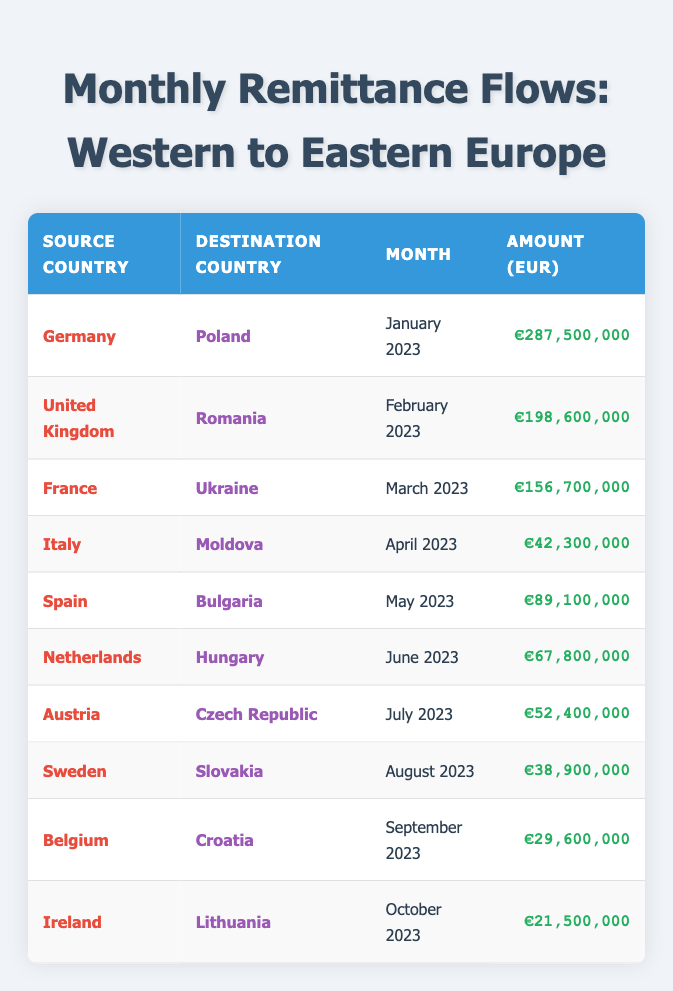What was the highest remittance flow recorded in the table? The highest remittance flow is found by scanning the "Amount (EUR)" column. The largest number listed is €287,500,000, which corresponds to Germany sending money to Poland in January 2023.
Answer: €287,500,000 How much money was sent from Italy to Moldova? By examining the table, I find that the amount sent from Italy to Moldova in April 2023 is €42,300,000 as indicated in the "Amount (EUR)" column.
Answer: €42,300,000 Which country received the least remittance in the table? Looking through the "Amount (EUR)" column, the smallest amount is €21,500,000 sent to Lithuania by Ireland in October 2023.
Answer: Lithuania What is the total amount remitted to Romania and Poland combined? First, I identify the amounts for Romania (€198,600,000) and Poland (€287,500,000). Adding these amounts together gives €198,600,000 + €287,500,000 = €486,100,000.
Answer: €486,100,000 Did any country send remittances in June 2023? A check of the data shows that the Netherlands sent remittances to Hungary in June 2023, confirming that remittances were indeed sent in that month.
Answer: Yes What is the average remittance amount across all the countries listed? To find the average, I sum all the amounts: €287,500,000 + €198,600,000 + €156,700,000 + €42,300,000 + €89,100,000 + €67,800,000 + €52,400,000 + €38,900,000 + €29,600,000 + €21,500,000 = €984,500,000. There are 10 entries, so the average is €984,500,000 / 10 = €98,450,000.
Answer: €98,450,000 Which country sent remittances to Slovakia? According to the table, Sweden sent remittances to Slovakia in August 2023. The source country is clearly listed next to Slovakia.
Answer: Sweden Was the amount sent from Belgium to Croatia higher than that from Ireland to Lithuania? The amount sent from Belgium to Croatia is €29,600,000 while the amount sent from Ireland to Lithuania is €21,500,000. Since €29,600,000 is greater than €21,500,000, this statement is true.
Answer: Yes How does the remittance from Spain to Bulgaria compare to that from France to Ukraine? Amounts are €89,100,000 from Spain to Bulgaria and €156,700,000 from France to Ukraine. Since €89,100,000 is less than €156,700,000, we conclude that the remittance from Spain is lower.
Answer: Lower 